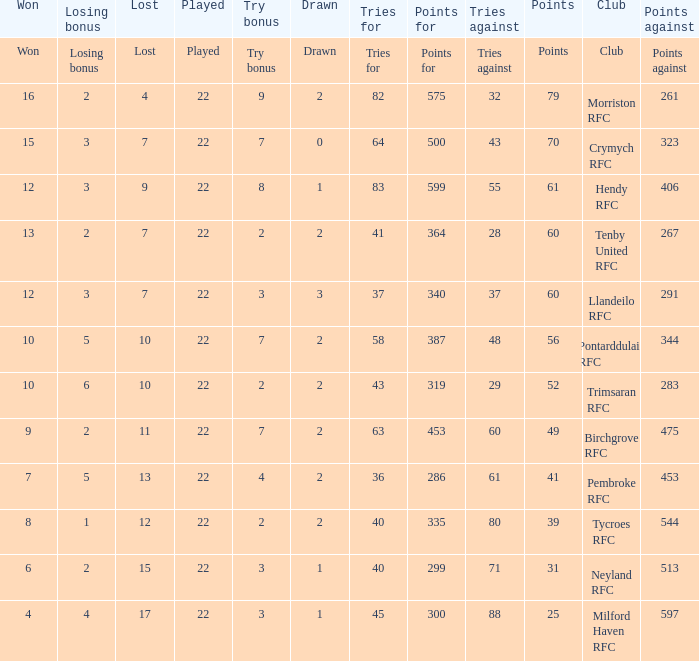Write the full table. {'header': ['Won', 'Losing bonus', 'Lost', 'Played', 'Try bonus', 'Drawn', 'Tries for', 'Points for', 'Tries against', 'Points', 'Club', 'Points against'], 'rows': [['Won', 'Losing bonus', 'Lost', 'Played', 'Try bonus', 'Drawn', 'Tries for', 'Points for', 'Tries against', 'Points', 'Club', 'Points against'], ['16', '2', '4', '22', '9', '2', '82', '575', '32', '79', 'Morriston RFC', '261'], ['15', '3', '7', '22', '7', '0', '64', '500', '43', '70', 'Crymych RFC', '323'], ['12', '3', '9', '22', '8', '1', '83', '599', '55', '61', 'Hendy RFC', '406'], ['13', '2', '7', '22', '2', '2', '41', '364', '28', '60', 'Tenby United RFC', '267'], ['12', '3', '7', '22', '3', '3', '37', '340', '37', '60', 'Llandeilo RFC', '291'], ['10', '5', '10', '22', '7', '2', '58', '387', '48', '56', 'Pontarddulais RFC', '344'], ['10', '6', '10', '22', '2', '2', '43', '319', '29', '52', 'Trimsaran RFC', '283'], ['9', '2', '11', '22', '7', '2', '63', '453', '60', '49', 'Birchgrove RFC', '475'], ['7', '5', '13', '22', '4', '2', '36', '286', '61', '41', 'Pembroke RFC', '453'], ['8', '1', '12', '22', '2', '2', '40', '335', '80', '39', 'Tycroes RFC', '544'], ['6', '2', '15', '22', '3', '1', '40', '299', '71', '31', 'Neyland RFC', '513'], ['4', '4', '17', '22', '3', '1', '45', '300', '88', '25', 'Milford Haven RFC', '597']]} What's the club with losing bonus being 1 Tycroes RFC. 